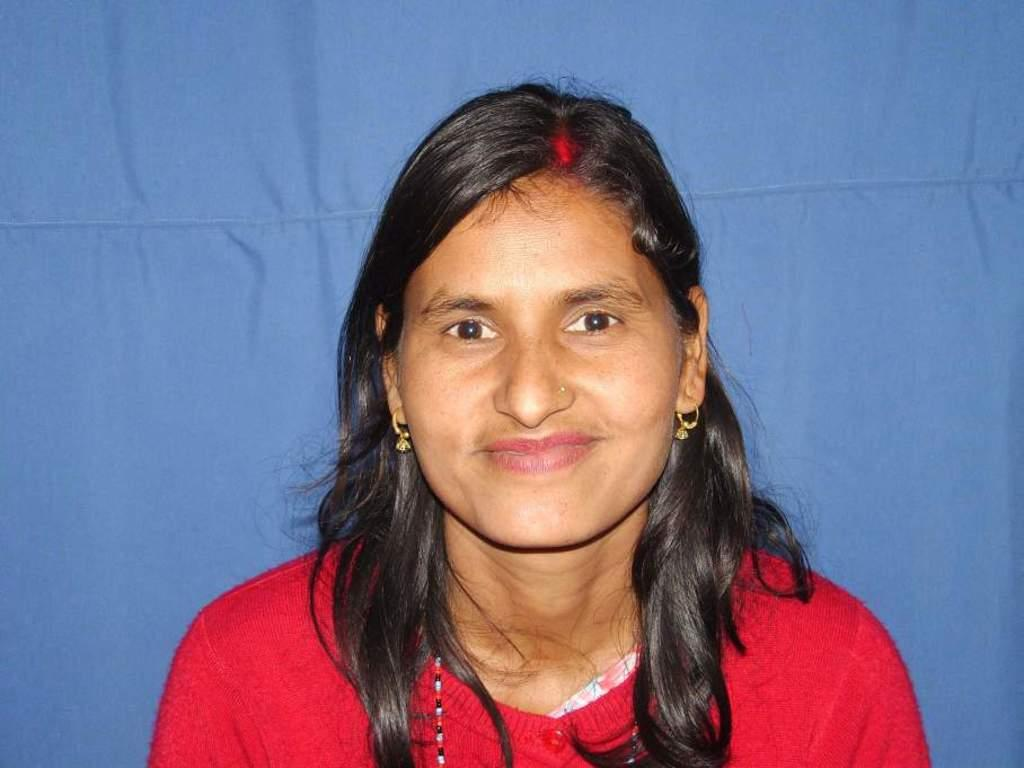Who is present in the image? There is a woman in the image. What is the woman doing in the image? The woman is smiling in the image. What is the woman wearing in the image? The woman is wearing a red sweater in the image. What color is the background of the image? The background of the image is blue. What type of flesh can be seen in the image? There is no flesh visible in the image; it features a woman wearing a red sweater against a blue background. What kind of steel structure is present in the image? There is no steel structure present in the image. 